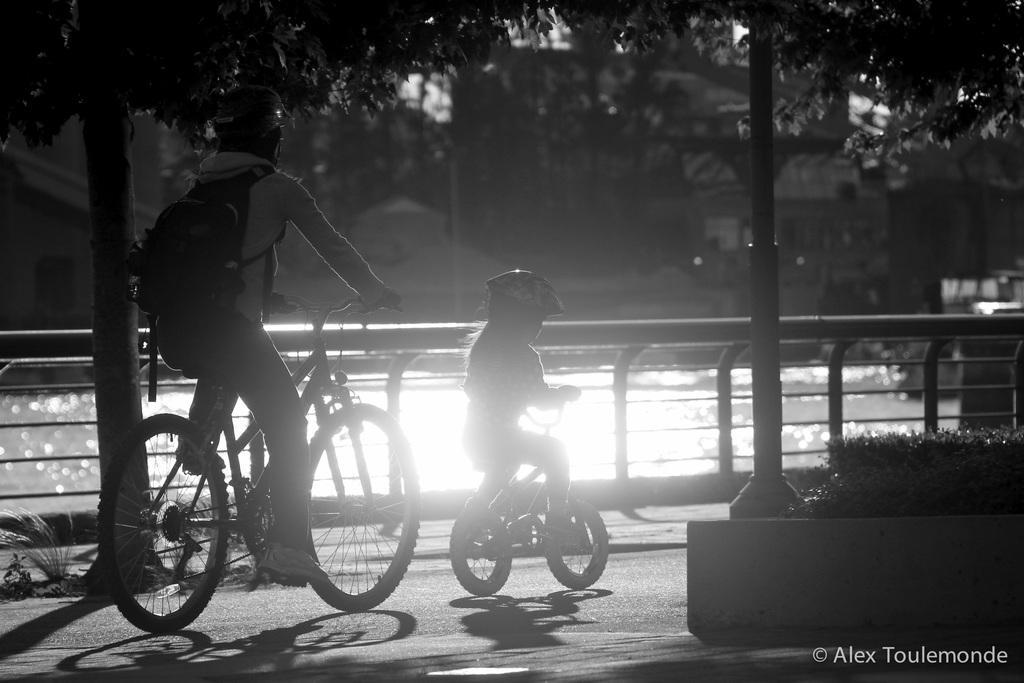Describe this image in one or two sentences. In this image on the left side there is one person who is sitting on a cycle and riding and he is wearing helmet and bag beside him there is another small cycle and on that cycle there is one small baby who is sitting and riding on the background there are trees and in the middle there is a river and on the bottom of the right corner there is a plant. 